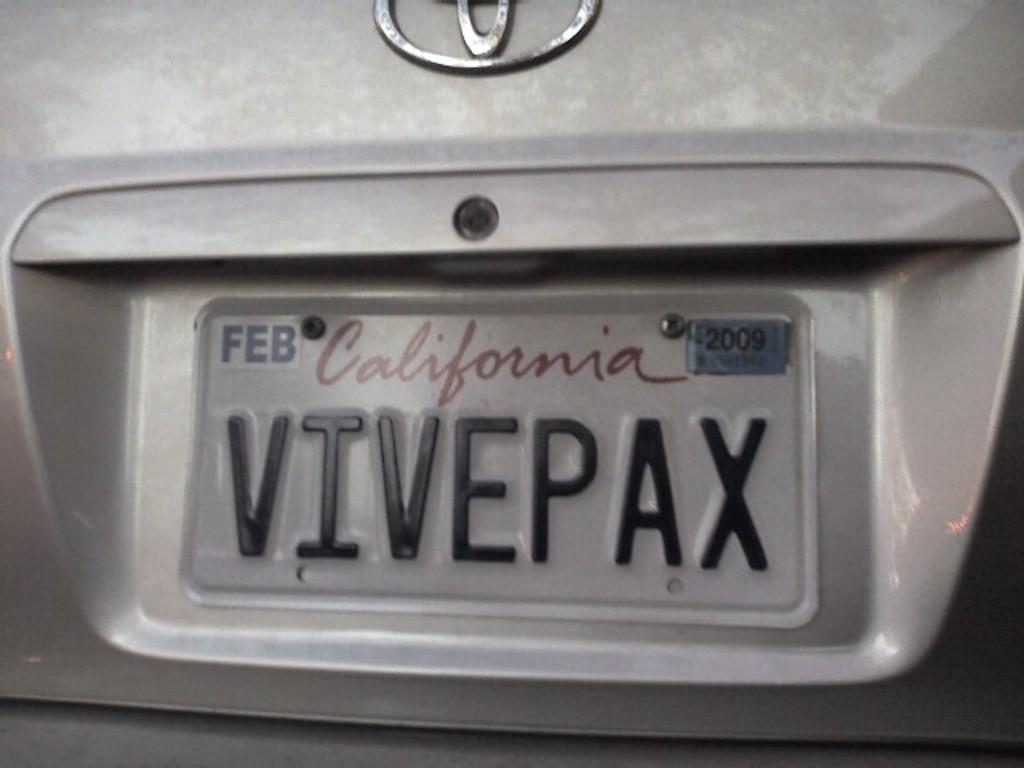What state is this license plate from?
Your answer should be compact. California. 